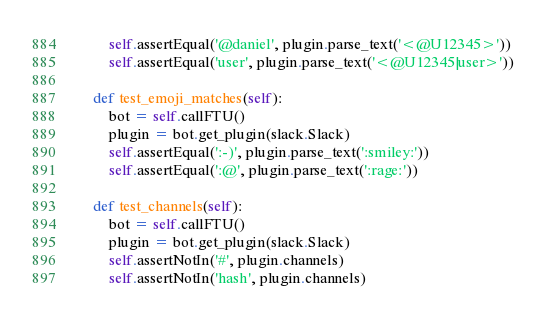Convert code to text. <code><loc_0><loc_0><loc_500><loc_500><_Python_>        self.assertEqual('@daniel', plugin.parse_text('<@U12345>'))
        self.assertEqual('user', plugin.parse_text('<@U12345|user>'))

    def test_emoji_matches(self):
        bot = self.callFTU()
        plugin = bot.get_plugin(slack.Slack)
        self.assertEqual(':-)', plugin.parse_text(':smiley:'))
        self.assertEqual(':@', plugin.parse_text(':rage:'))

    def test_channels(self):
        bot = self.callFTU()
        plugin = bot.get_plugin(slack.Slack)
        self.assertNotIn('#', plugin.channels)
        self.assertNotIn('hash', plugin.channels)
</code> 